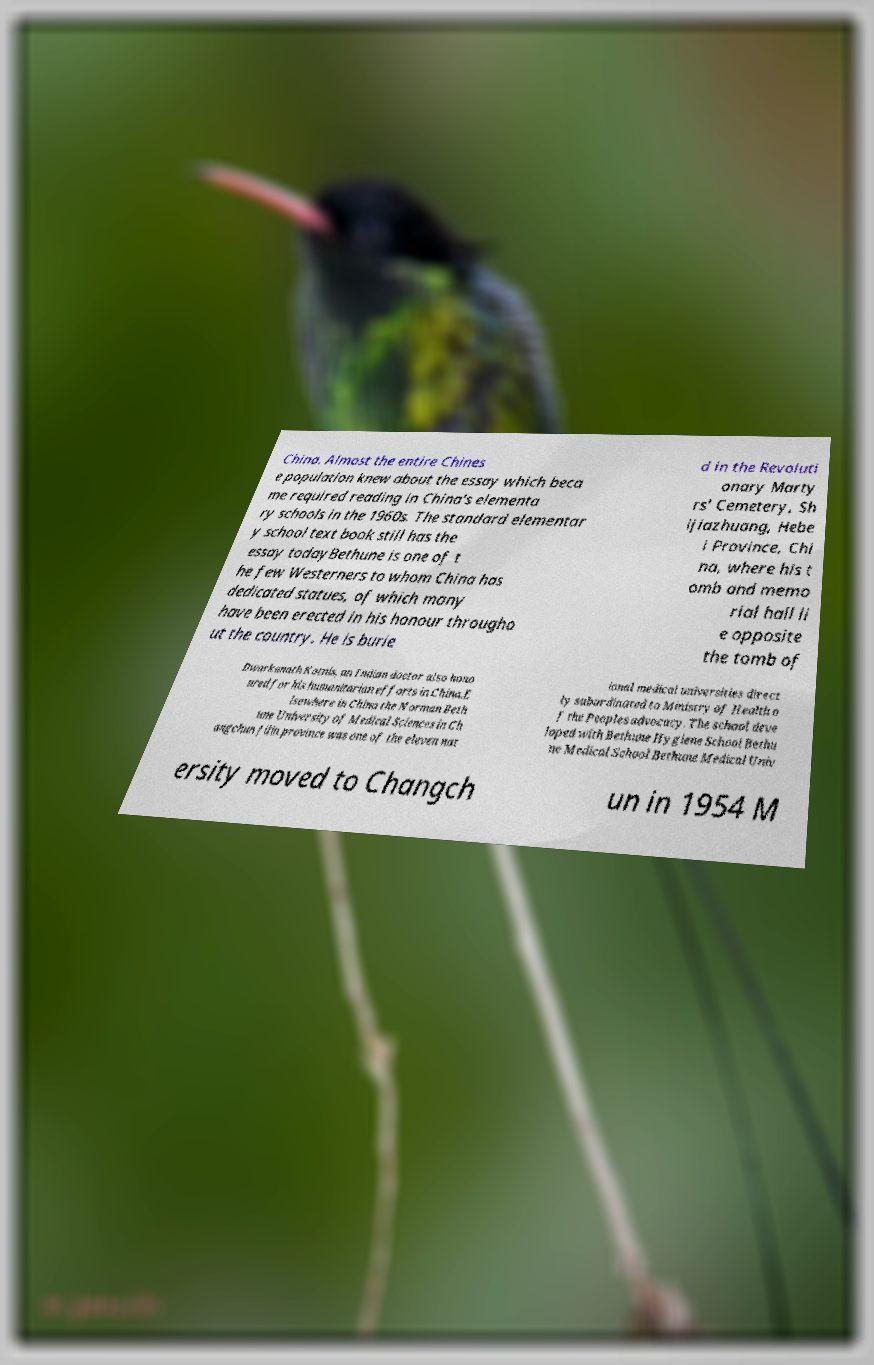Can you accurately transcribe the text from the provided image for me? China. Almost the entire Chines e population knew about the essay which beca me required reading in China's elementa ry schools in the 1960s. The standard elementar y school text book still has the essay todayBethune is one of t he few Westerners to whom China has dedicated statues, of which many have been erected in his honour througho ut the country. He is burie d in the Revoluti onary Marty rs' Cemetery, Sh ijiazhuang, Hebe i Province, Chi na, where his t omb and memo rial hall li e opposite the tomb of Dwarkanath Kotnis, an Indian doctor also hono ured for his humanitarian efforts in China.E lsewhere in China the Norman Beth une University of Medical Sciences in Ch angchun Jilin province was one of the eleven nat ional medical universities direct ly subordinated to Ministry of Health o f the Peoples advocacy. The school deve loped with Bethune Hygiene School Bethu ne Medical School Bethune Medical Univ ersity moved to Changch un in 1954 M 